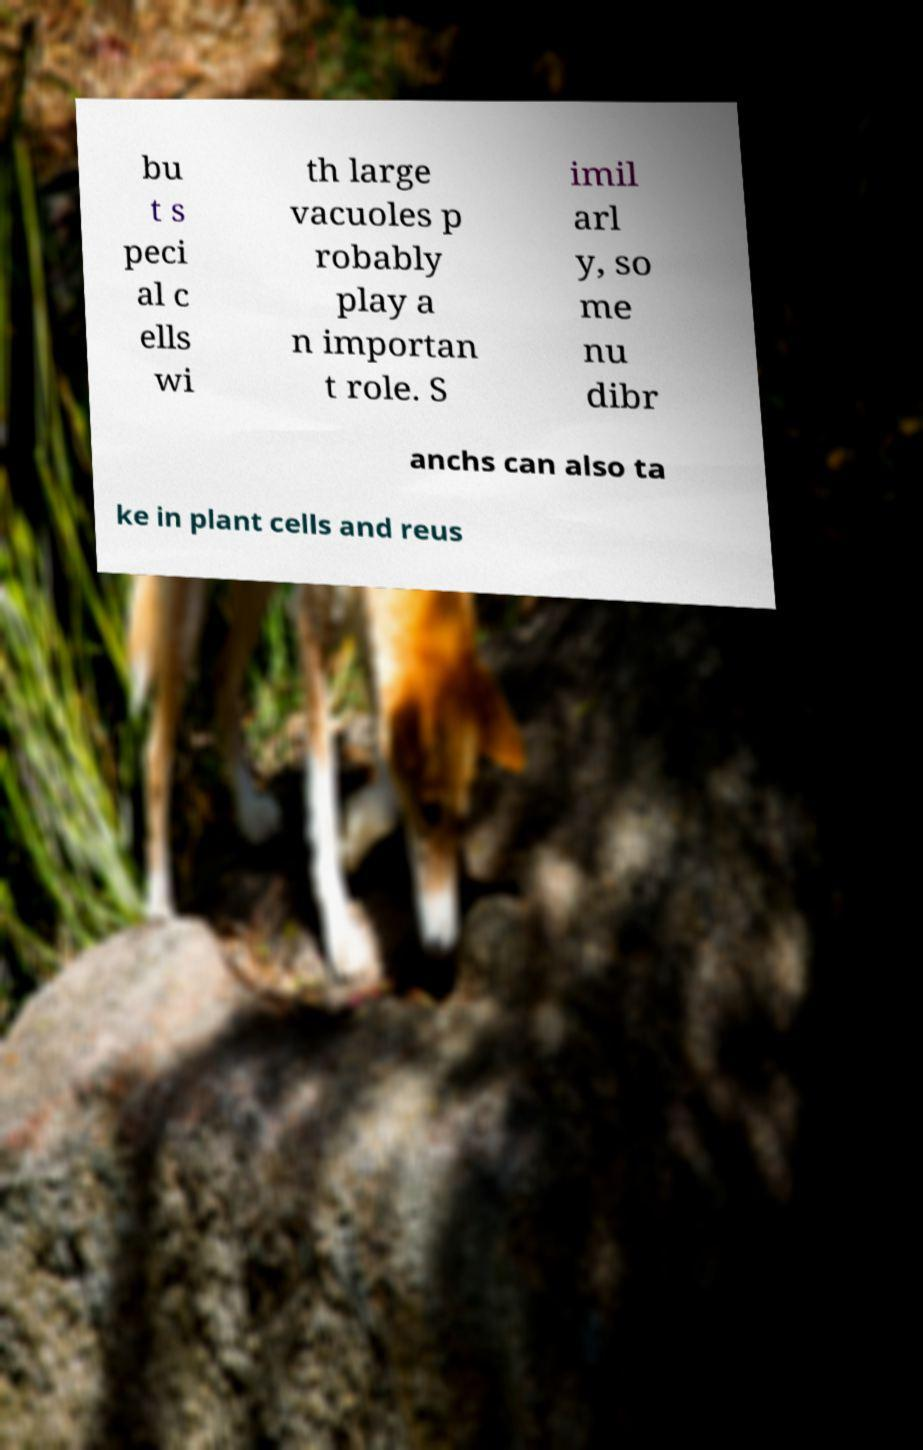I need the written content from this picture converted into text. Can you do that? bu t s peci al c ells wi th large vacuoles p robably play a n importan t role. S imil arl y, so me nu dibr anchs can also ta ke in plant cells and reus 